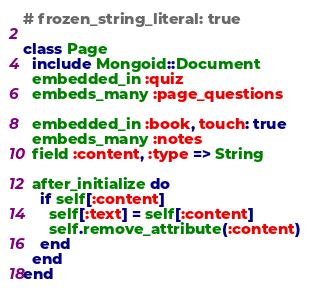<code> <loc_0><loc_0><loc_500><loc_500><_Ruby_># frozen_string_literal: true

class Page
  include Mongoid::Document
  embedded_in :quiz
  embeds_many :page_questions

  embedded_in :book, touch: true
  embeds_many :notes
  field :content, :type => String

  after_initialize do
    if self[:content]
      self[:text] = self[:content]
      self.remove_attribute(:content)
    end
  end
end
</code> 